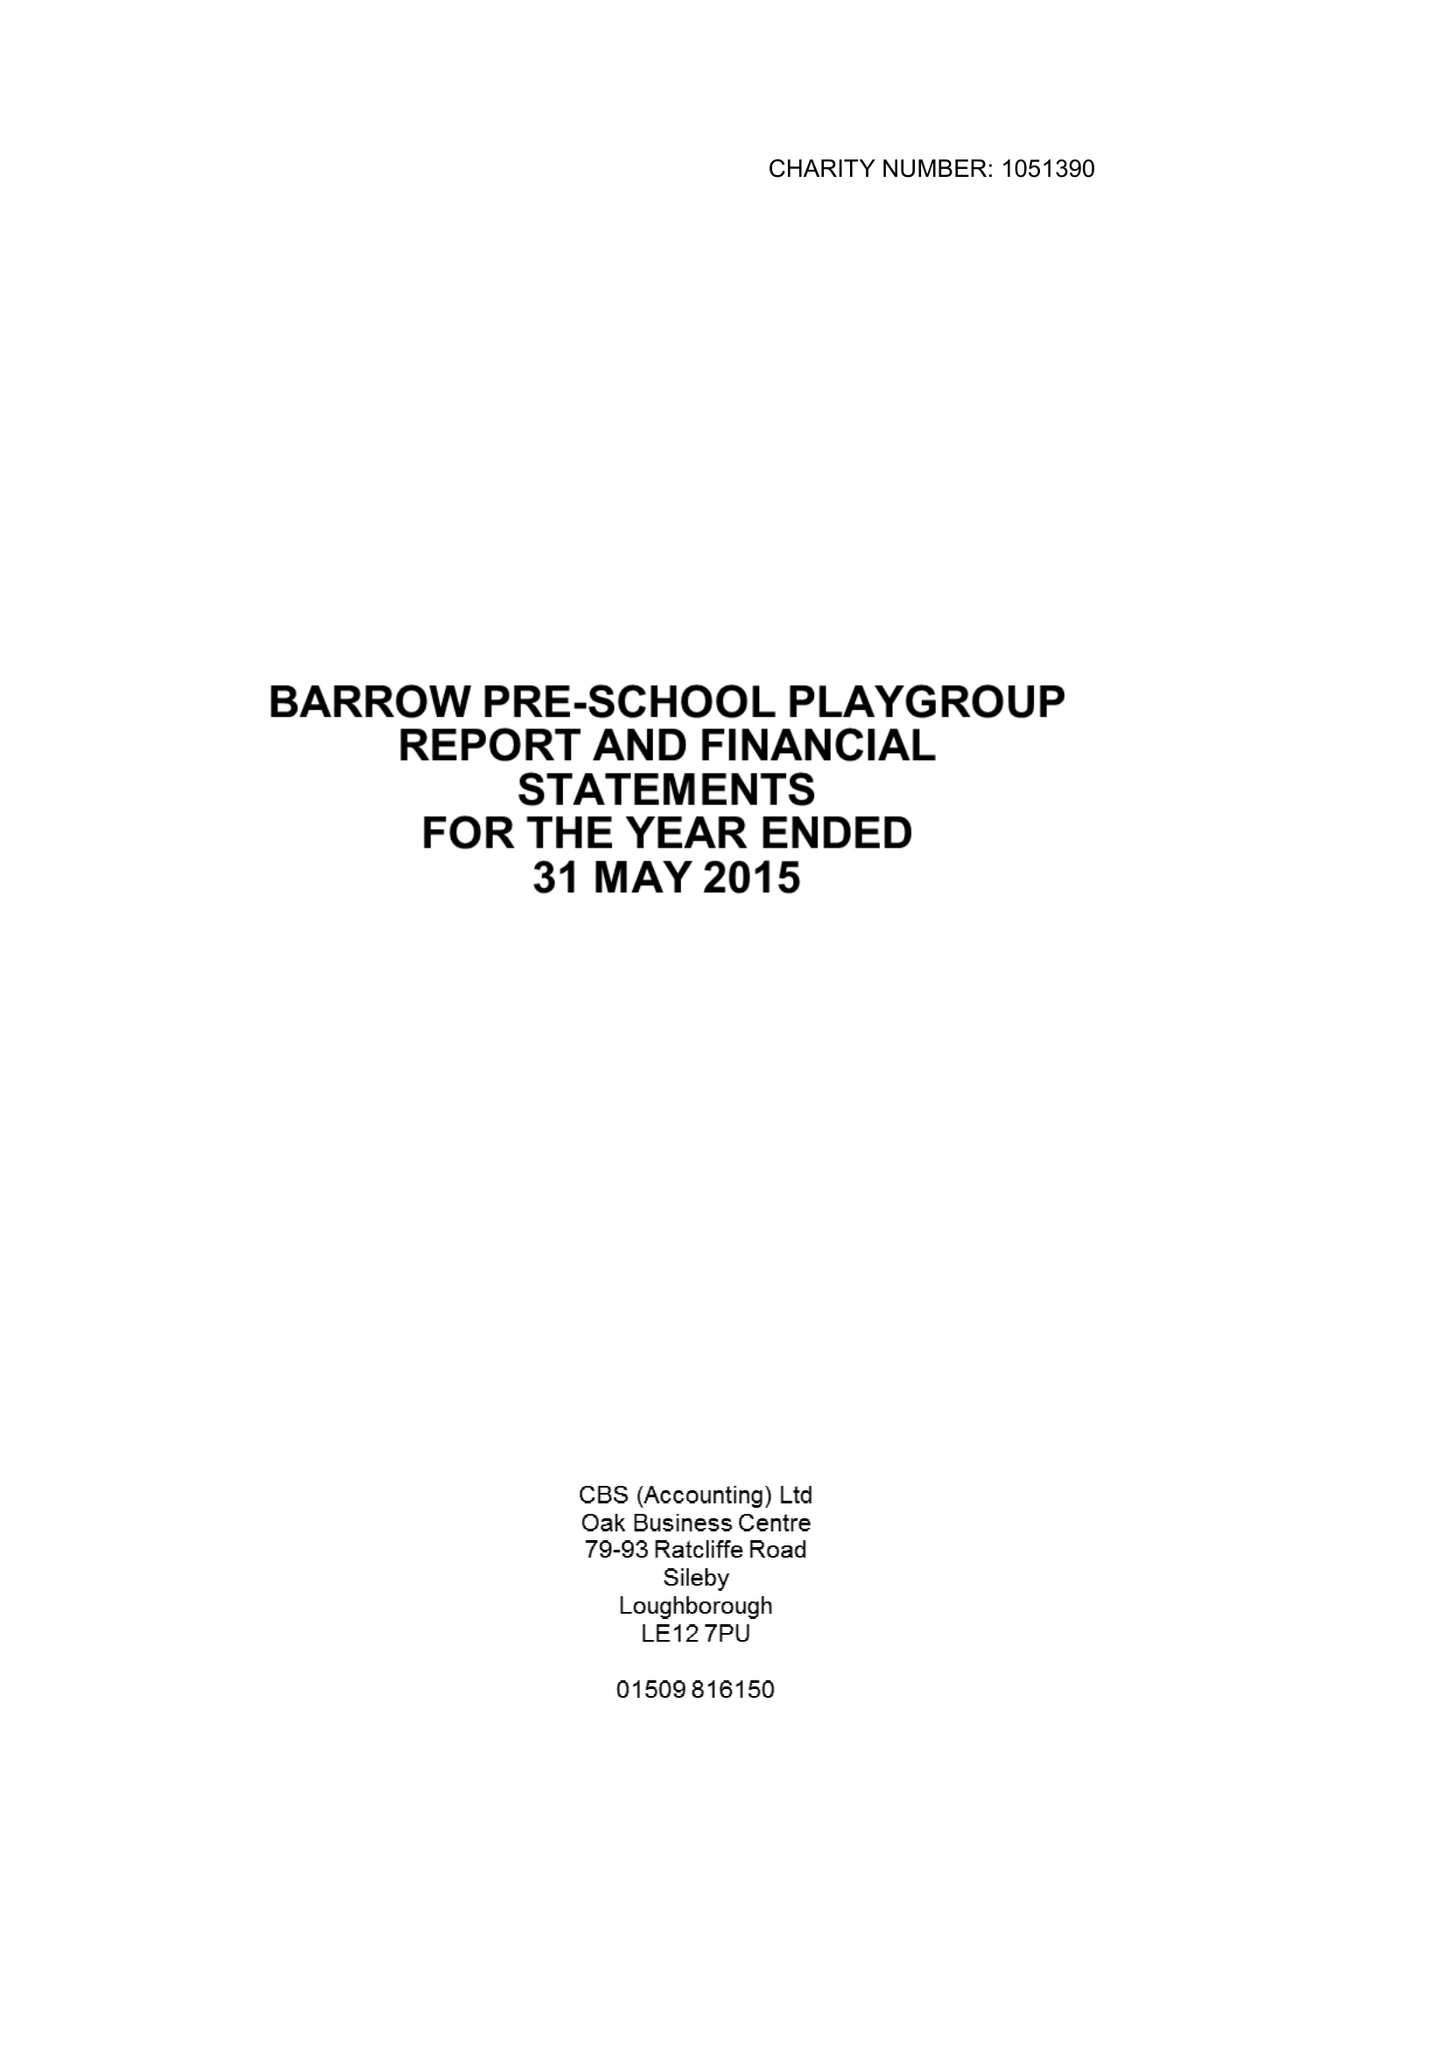What is the value for the charity_number?
Answer the question using a single word or phrase. 1051390 